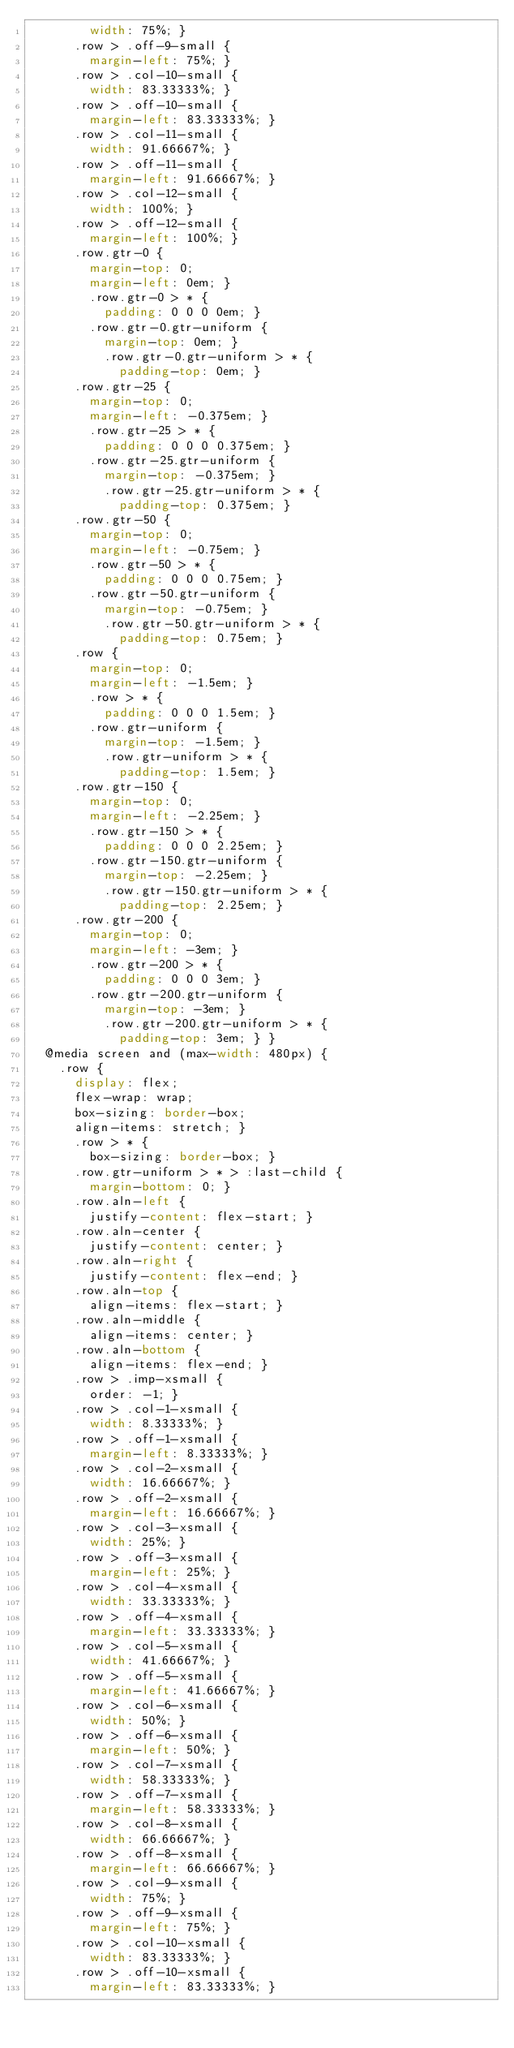<code> <loc_0><loc_0><loc_500><loc_500><_CSS_>        width: 75%; }
      .row > .off-9-small {
        margin-left: 75%; }
      .row > .col-10-small {
        width: 83.33333%; }
      .row > .off-10-small {
        margin-left: 83.33333%; }
      .row > .col-11-small {
        width: 91.66667%; }
      .row > .off-11-small {
        margin-left: 91.66667%; }
      .row > .col-12-small {
        width: 100%; }
      .row > .off-12-small {
        margin-left: 100%; }
      .row.gtr-0 {
        margin-top: 0;
        margin-left: 0em; }
        .row.gtr-0 > * {
          padding: 0 0 0 0em; }
        .row.gtr-0.gtr-uniform {
          margin-top: 0em; }
          .row.gtr-0.gtr-uniform > * {
            padding-top: 0em; }
      .row.gtr-25 {
        margin-top: 0;
        margin-left: -0.375em; }
        .row.gtr-25 > * {
          padding: 0 0 0 0.375em; }
        .row.gtr-25.gtr-uniform {
          margin-top: -0.375em; }
          .row.gtr-25.gtr-uniform > * {
            padding-top: 0.375em; }
      .row.gtr-50 {
        margin-top: 0;
        margin-left: -0.75em; }
        .row.gtr-50 > * {
          padding: 0 0 0 0.75em; }
        .row.gtr-50.gtr-uniform {
          margin-top: -0.75em; }
          .row.gtr-50.gtr-uniform > * {
            padding-top: 0.75em; }
      .row {
        margin-top: 0;
        margin-left: -1.5em; }
        .row > * {
          padding: 0 0 0 1.5em; }
        .row.gtr-uniform {
          margin-top: -1.5em; }
          .row.gtr-uniform > * {
            padding-top: 1.5em; }
      .row.gtr-150 {
        margin-top: 0;
        margin-left: -2.25em; }
        .row.gtr-150 > * {
          padding: 0 0 0 2.25em; }
        .row.gtr-150.gtr-uniform {
          margin-top: -2.25em; }
          .row.gtr-150.gtr-uniform > * {
            padding-top: 2.25em; }
      .row.gtr-200 {
        margin-top: 0;
        margin-left: -3em; }
        .row.gtr-200 > * {
          padding: 0 0 0 3em; }
        .row.gtr-200.gtr-uniform {
          margin-top: -3em; }
          .row.gtr-200.gtr-uniform > * {
            padding-top: 3em; } }
  @media screen and (max-width: 480px) {
    .row {
      display: flex;
      flex-wrap: wrap;
      box-sizing: border-box;
      align-items: stretch; }
      .row > * {
        box-sizing: border-box; }
      .row.gtr-uniform > * > :last-child {
        margin-bottom: 0; }
      .row.aln-left {
        justify-content: flex-start; }
      .row.aln-center {
        justify-content: center; }
      .row.aln-right {
        justify-content: flex-end; }
      .row.aln-top {
        align-items: flex-start; }
      .row.aln-middle {
        align-items: center; }
      .row.aln-bottom {
        align-items: flex-end; }
      .row > .imp-xsmall {
        order: -1; }
      .row > .col-1-xsmall {
        width: 8.33333%; }
      .row > .off-1-xsmall {
        margin-left: 8.33333%; }
      .row > .col-2-xsmall {
        width: 16.66667%; }
      .row > .off-2-xsmall {
        margin-left: 16.66667%; }
      .row > .col-3-xsmall {
        width: 25%; }
      .row > .off-3-xsmall {
        margin-left: 25%; }
      .row > .col-4-xsmall {
        width: 33.33333%; }
      .row > .off-4-xsmall {
        margin-left: 33.33333%; }
      .row > .col-5-xsmall {
        width: 41.66667%; }
      .row > .off-5-xsmall {
        margin-left: 41.66667%; }
      .row > .col-6-xsmall {
        width: 50%; }
      .row > .off-6-xsmall {
        margin-left: 50%; }
      .row > .col-7-xsmall {
        width: 58.33333%; }
      .row > .off-7-xsmall {
        margin-left: 58.33333%; }
      .row > .col-8-xsmall {
        width: 66.66667%; }
      .row > .off-8-xsmall {
        margin-left: 66.66667%; }
      .row > .col-9-xsmall {
        width: 75%; }
      .row > .off-9-xsmall {
        margin-left: 75%; }
      .row > .col-10-xsmall {
        width: 83.33333%; }
      .row > .off-10-xsmall {
        margin-left: 83.33333%; }</code> 